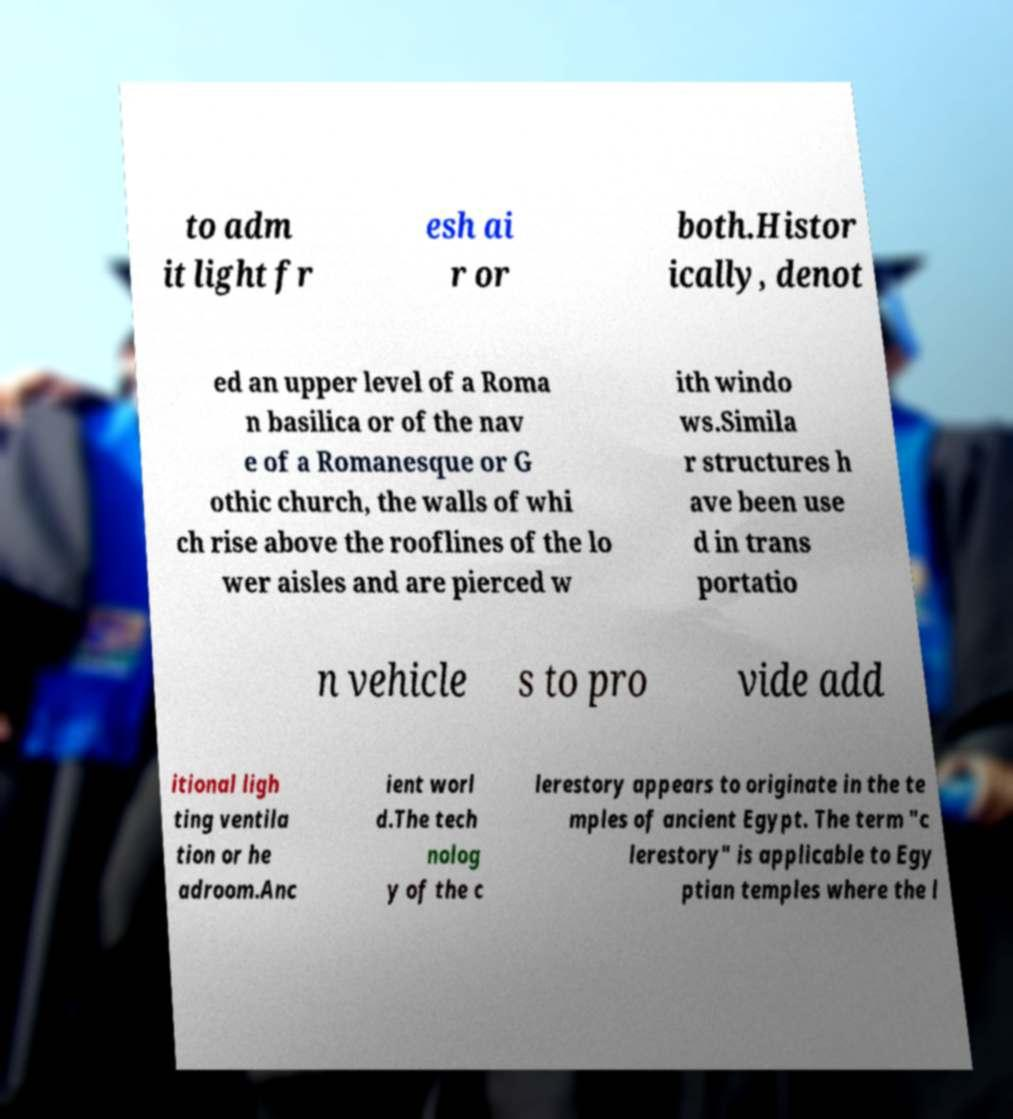Could you extract and type out the text from this image? to adm it light fr esh ai r or both.Histor ically, denot ed an upper level of a Roma n basilica or of the nav e of a Romanesque or G othic church, the walls of whi ch rise above the rooflines of the lo wer aisles and are pierced w ith windo ws.Simila r structures h ave been use d in trans portatio n vehicle s to pro vide add itional ligh ting ventila tion or he adroom.Anc ient worl d.The tech nolog y of the c lerestory appears to originate in the te mples of ancient Egypt. The term "c lerestory" is applicable to Egy ptian temples where the l 